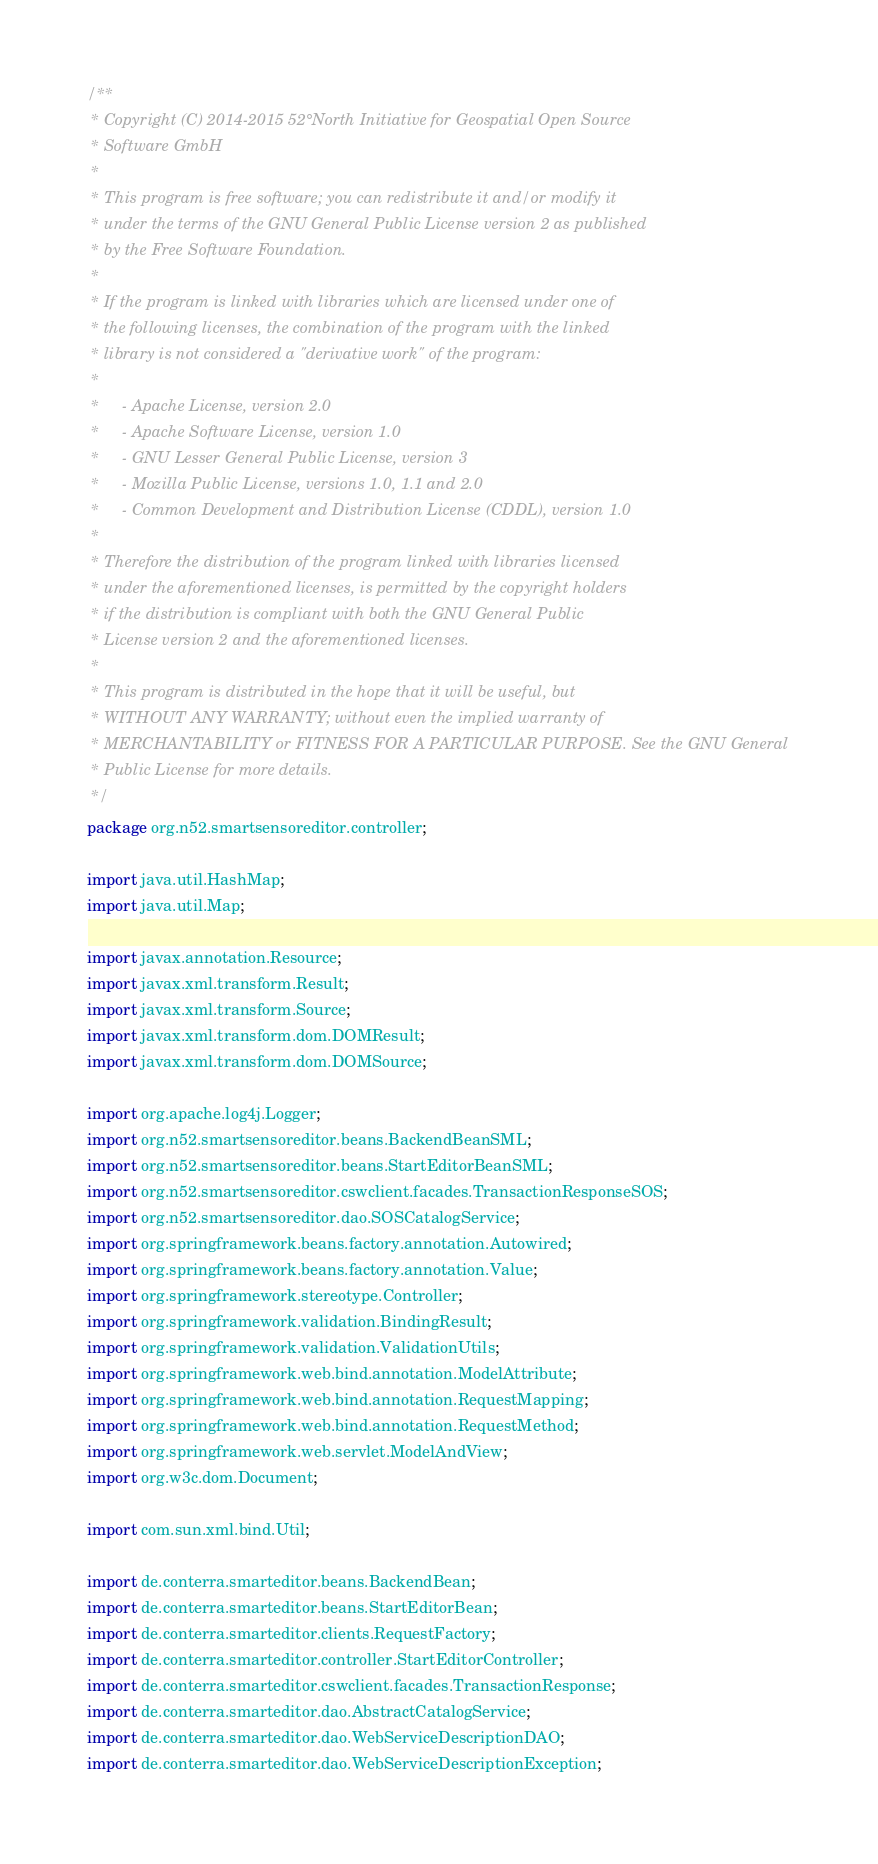<code> <loc_0><loc_0><loc_500><loc_500><_Java_>/**
 * Copyright (C) 2014-2015 52°North Initiative for Geospatial Open Source
 * Software GmbH
 *
 * This program is free software; you can redistribute it and/or modify it
 * under the terms of the GNU General Public License version 2 as published
 * by the Free Software Foundation.
 *
 * If the program is linked with libraries which are licensed under one of
 * the following licenses, the combination of the program with the linked
 * library is not considered a "derivative work" of the program:
 *
 *     - Apache License, version 2.0
 *     - Apache Software License, version 1.0
 *     - GNU Lesser General Public License, version 3
 *     - Mozilla Public License, versions 1.0, 1.1 and 2.0
 *     - Common Development and Distribution License (CDDL), version 1.0
 *
 * Therefore the distribution of the program linked with libraries licensed
 * under the aforementioned licenses, is permitted by the copyright holders
 * if the distribution is compliant with both the GNU General Public
 * License version 2 and the aforementioned licenses.
 *
 * This program is distributed in the hope that it will be useful, but
 * WITHOUT ANY WARRANTY; without even the implied warranty of
 * MERCHANTABILITY or FITNESS FOR A PARTICULAR PURPOSE. See the GNU General
 * Public License for more details.
 */
package org.n52.smartsensoreditor.controller;

import java.util.HashMap;
import java.util.Map;

import javax.annotation.Resource;
import javax.xml.transform.Result;
import javax.xml.transform.Source;
import javax.xml.transform.dom.DOMResult;
import javax.xml.transform.dom.DOMSource;

import org.apache.log4j.Logger;
import org.n52.smartsensoreditor.beans.BackendBeanSML;
import org.n52.smartsensoreditor.beans.StartEditorBeanSML;
import org.n52.smartsensoreditor.cswclient.facades.TransactionResponseSOS;
import org.n52.smartsensoreditor.dao.SOSCatalogService;
import org.springframework.beans.factory.annotation.Autowired;
import org.springframework.beans.factory.annotation.Value;
import org.springframework.stereotype.Controller;
import org.springframework.validation.BindingResult;
import org.springframework.validation.ValidationUtils;
import org.springframework.web.bind.annotation.ModelAttribute;
import org.springframework.web.bind.annotation.RequestMapping;
import org.springframework.web.bind.annotation.RequestMethod;
import org.springframework.web.servlet.ModelAndView;
import org.w3c.dom.Document;

import com.sun.xml.bind.Util;

import de.conterra.smarteditor.beans.BackendBean;
import de.conterra.smarteditor.beans.StartEditorBean;
import de.conterra.smarteditor.clients.RequestFactory;
import de.conterra.smarteditor.controller.StartEditorController;
import de.conterra.smarteditor.cswclient.facades.TransactionResponse;
import de.conterra.smarteditor.dao.AbstractCatalogService;
import de.conterra.smarteditor.dao.WebServiceDescriptionDAO;
import de.conterra.smarteditor.dao.WebServiceDescriptionException;</code> 